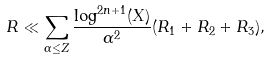Convert formula to latex. <formula><loc_0><loc_0><loc_500><loc_500>R \ll \sum _ { \alpha \leq Z } \frac { \log ^ { 2 n + 1 } ( X ) } { \alpha ^ { 2 } } ( R _ { 1 } + R _ { 2 } + R _ { 3 } ) ,</formula> 